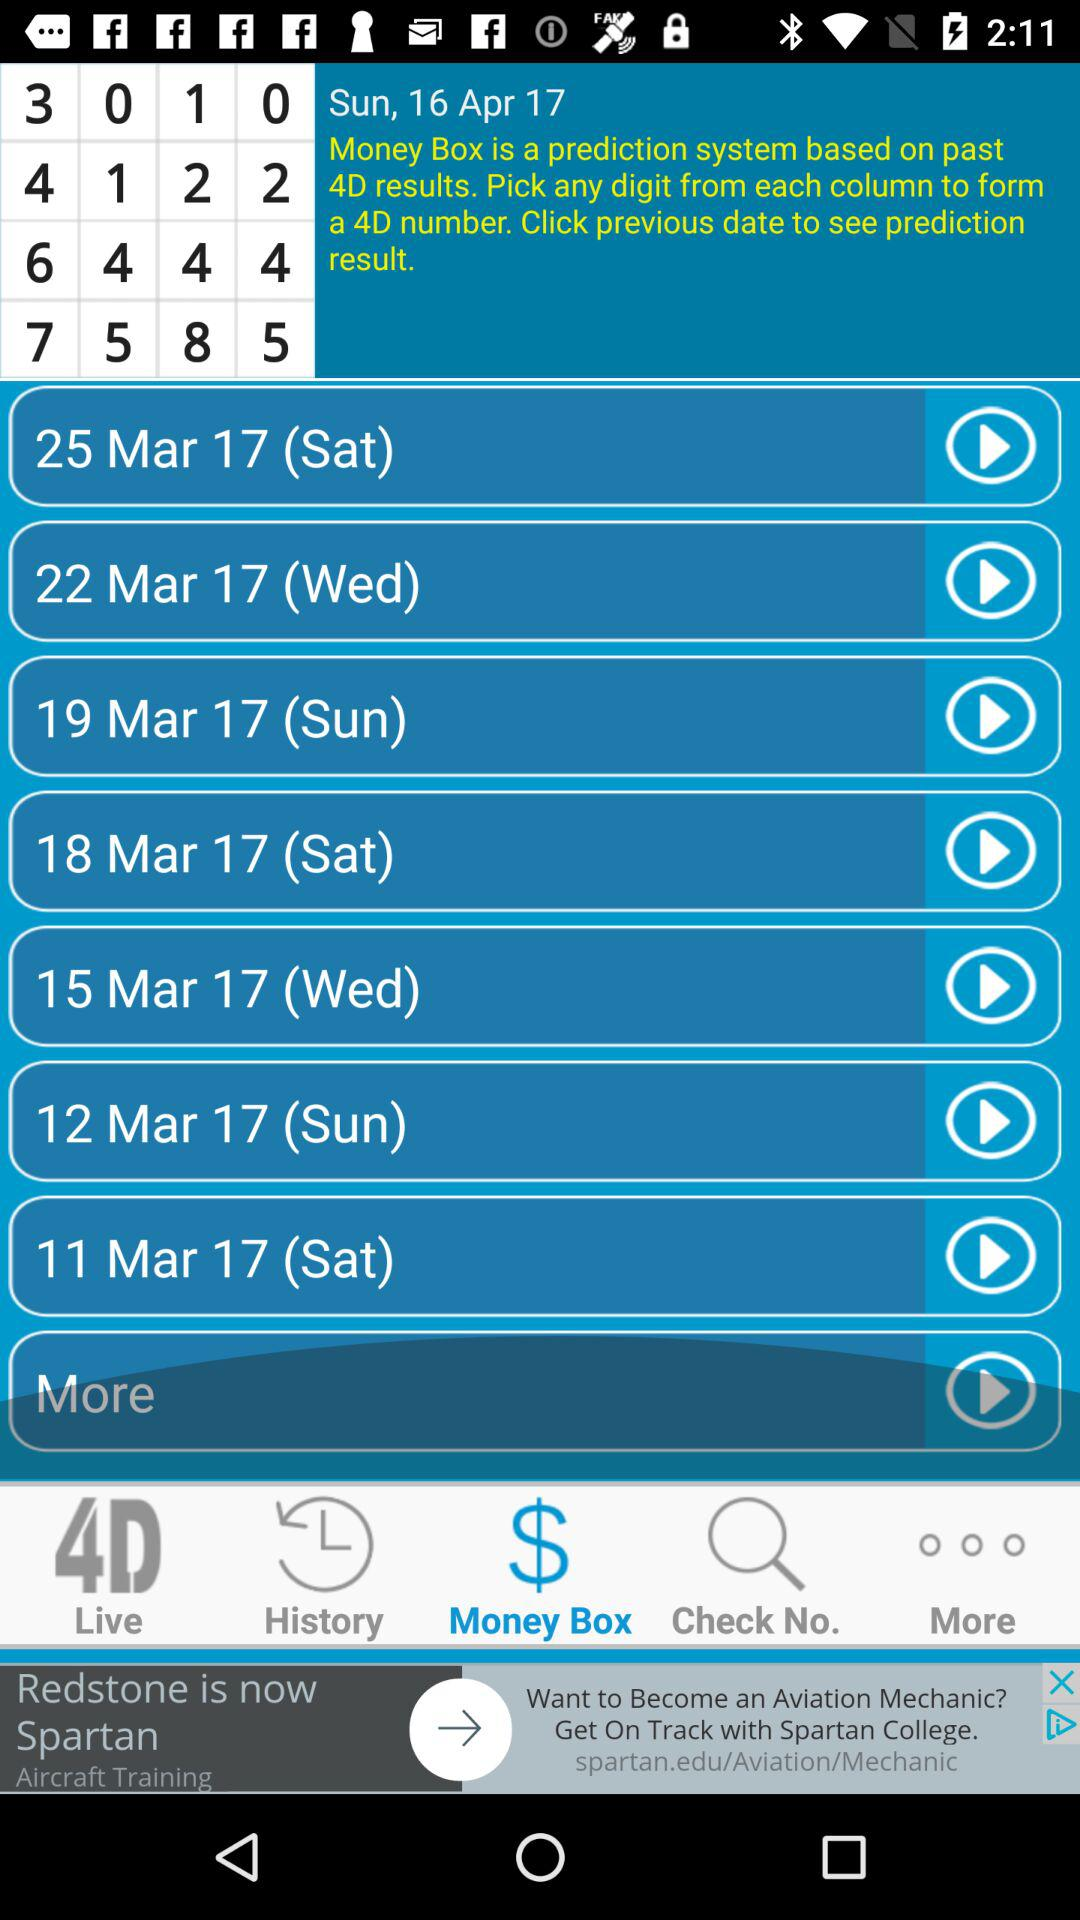Which tab is selected? The selected tab is "Money Box". 